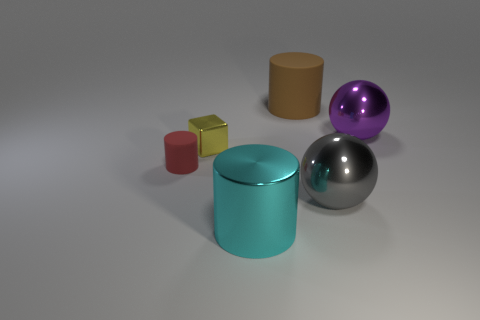Add 1 purple balls. How many objects exist? 7 Subtract all big cylinders. How many cylinders are left? 1 Subtract all cubes. How many objects are left? 5 Subtract 0 gray cubes. How many objects are left? 6 Subtract all large purple shiny things. Subtract all large objects. How many objects are left? 1 Add 3 brown cylinders. How many brown cylinders are left? 4 Add 4 small metal blocks. How many small metal blocks exist? 5 